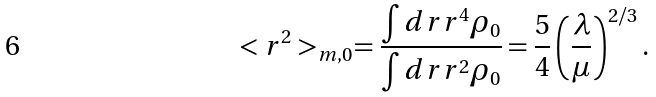<formula> <loc_0><loc_0><loc_500><loc_500>< r ^ { 2 } > _ { m , 0 } = \frac { \int d r r ^ { 4 } \rho _ { 0 } } { \int d r r ^ { 2 } \rho _ { 0 } } = \frac { 5 } { 4 } \left ( \frac { \lambda } { \mu } \right ) ^ { 2 / 3 } .</formula> 